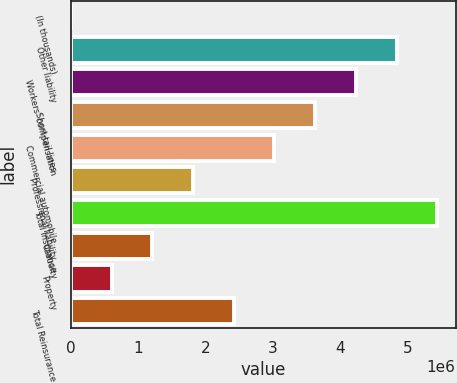Convert chart. <chart><loc_0><loc_0><loc_500><loc_500><bar_chart><fcel>(In thousands)<fcel>Other liability<fcel>Workers' compensation<fcel>Short-tail lines<fcel>Commercial automobile<fcel>Professional liability<fcel>Total Insurance<fcel>Casualty<fcel>Property<fcel>Total Reinsurance<nl><fcel>2015<fcel>4.83289e+06<fcel>4.22903e+06<fcel>3.62517e+06<fcel>3.02131e+06<fcel>1.81359e+06<fcel>5.43675e+06<fcel>1.20973e+06<fcel>605874<fcel>2.41745e+06<nl></chart> 